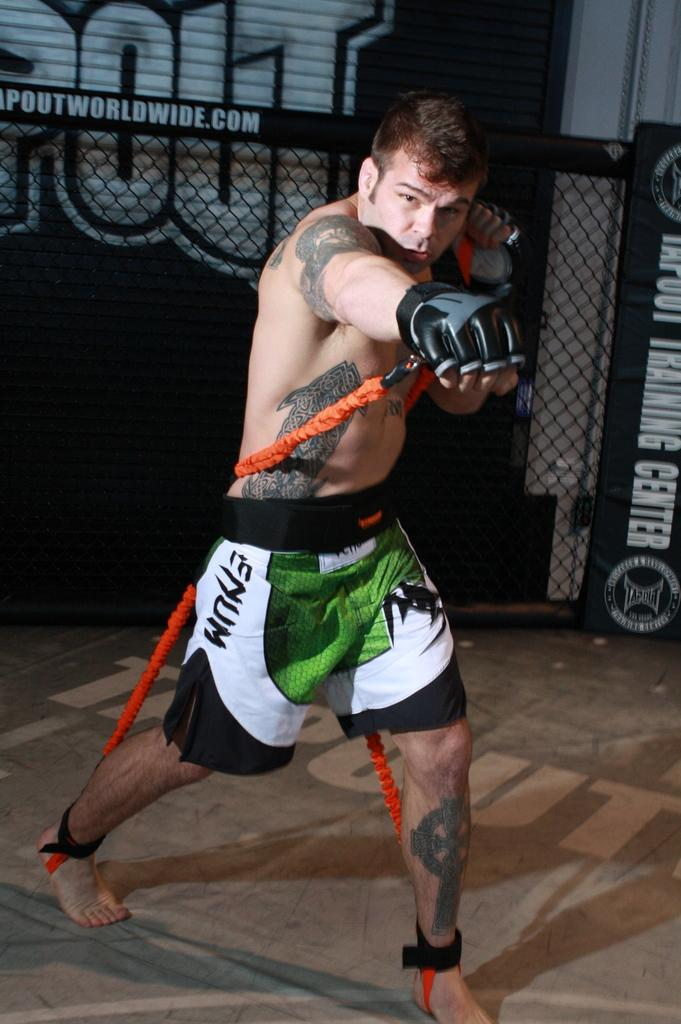<image>
Create a compact narrative representing the image presented. a man with shorts that has the letter M on it 